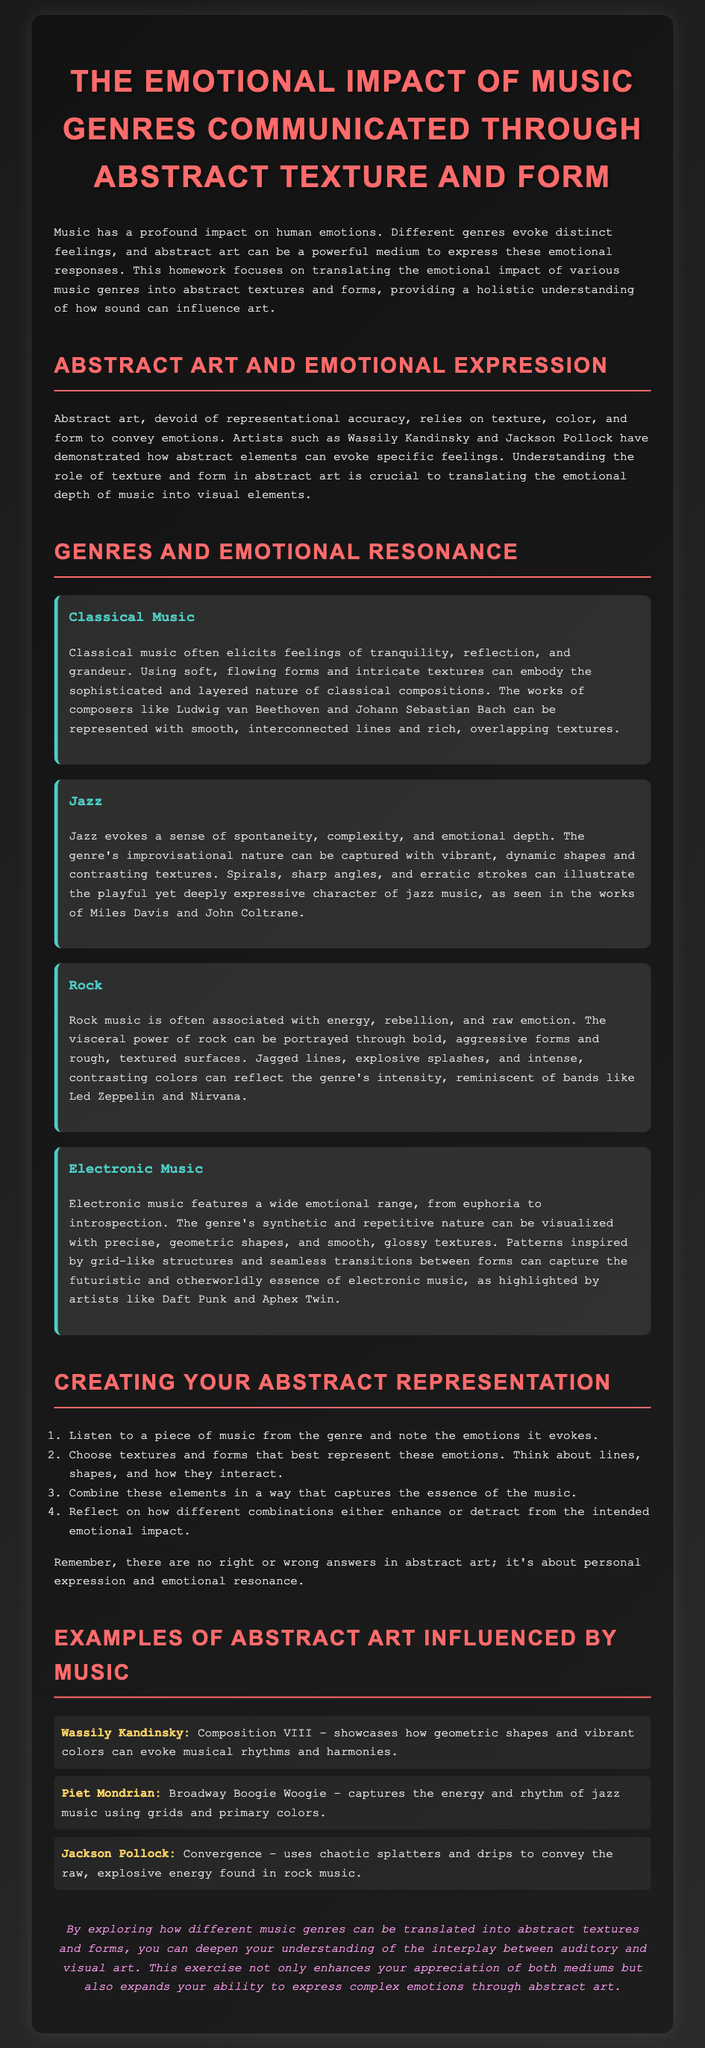What is the title of the document? The title is stated in the <title> tag of the document, which is "The Emotional Impact of Music Genres in Abstract Art."
Answer: The Emotional Impact of Music Genres in Abstract Art What is one emotional response elicited by classical music? The document provides specific feelings associated with classical music, mentioning tranquility.
Answer: Tranquility Which artist is known for the work "Composition VIII"? The document states that Wassily Kandinsky is the artist associated with this work.
Answer: Wassily Kandinsky What type of shapes represent electronic music? The document specifies that precise, geometric shapes visualize the essence of electronic music.
Answer: Geometric shapes What color is used predominantly in Piet Mondrian's "Broadway Boogie Woogie"? The document notes that primary colors are prominent in this artwork.
Answer: Primary colors Which genre is characterized by the use of spontaneous forms? The document indicates that jazz is the genre that embodies spontaneity and complexity.
Answer: Jazz What do bold forms in abstract art represent in the context of rock music? According to the document, bold, aggressive forms convey the visceral power of rock music.
Answer: Visceral power What is the last step in creating your abstract representation? The document outlines the steps and concludes with reflecting on different combinations.
Answer: Reflect on combinations How does the document suggest abstract art can enhance appreciation of both mediums? The conclusion explains that exploring music genres translated into abstract art deepens understanding, enhancing appreciation.
Answer: Deepens understanding 